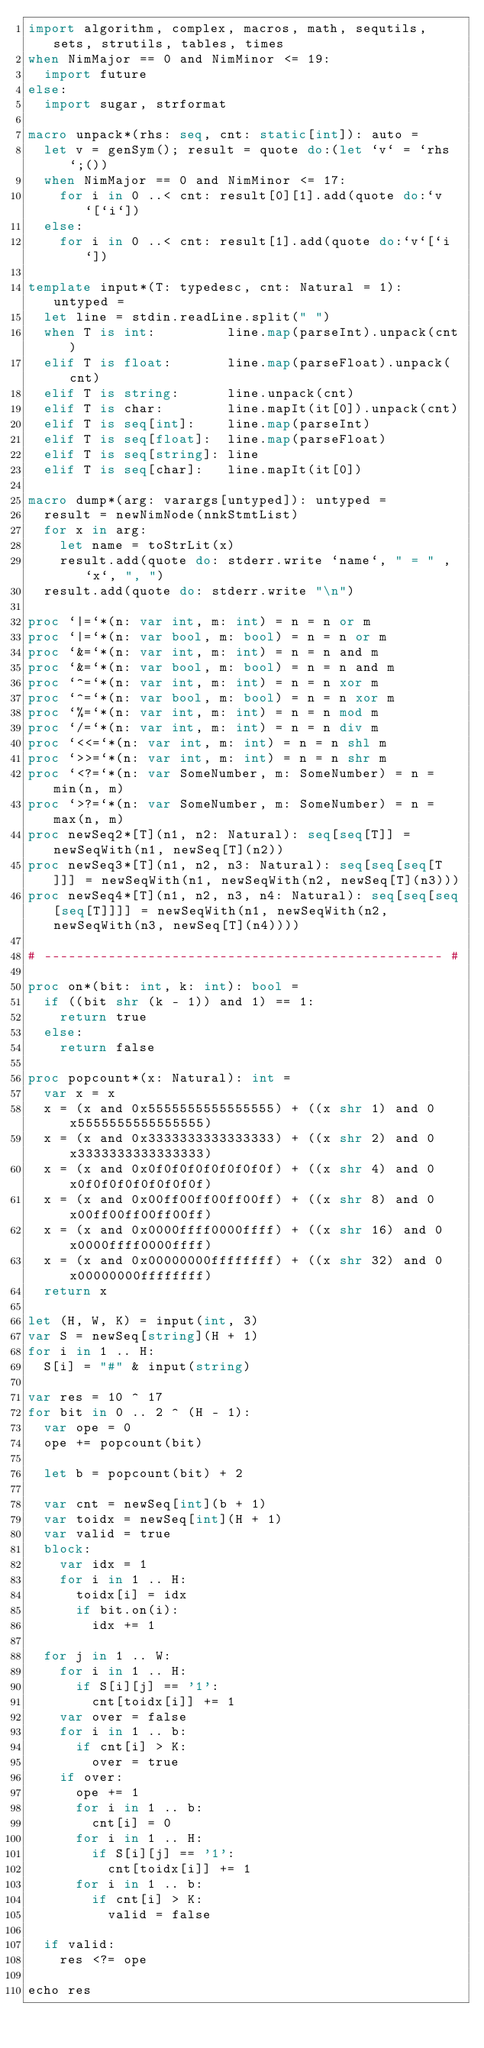<code> <loc_0><loc_0><loc_500><loc_500><_Nim_>import algorithm, complex, macros, math, sequtils, sets, strutils, tables, times
when NimMajor == 0 and NimMinor <= 19:
  import future
else:
  import sugar, strformat

macro unpack*(rhs: seq, cnt: static[int]): auto =
  let v = genSym(); result = quote do:(let `v` = `rhs`;())
  when NimMajor == 0 and NimMinor <= 17:
    for i in 0 ..< cnt: result[0][1].add(quote do:`v`[`i`])
  else:
    for i in 0 ..< cnt: result[1].add(quote do:`v`[`i`])

template input*(T: typedesc, cnt: Natural = 1): untyped =
  let line = stdin.readLine.split(" ")
  when T is int:         line.map(parseInt).unpack(cnt)
  elif T is float:       line.map(parseFloat).unpack(cnt)
  elif T is string:      line.unpack(cnt)
  elif T is char:        line.mapIt(it[0]).unpack(cnt)
  elif T is seq[int]:    line.map(parseInt)
  elif T is seq[float]:  line.map(parseFloat)
  elif T is seq[string]: line
  elif T is seq[char]:   line.mapIt(it[0])

macro dump*(arg: varargs[untyped]): untyped =
  result = newNimNode(nnkStmtList)
  for x in arg:
    let name = toStrLit(x)
    result.add(quote do: stderr.write `name`, " = " , `x`, ", ")
  result.add(quote do: stderr.write "\n")

proc `|=`*(n: var int, m: int) = n = n or m
proc `|=`*(n: var bool, m: bool) = n = n or m
proc `&=`*(n: var int, m: int) = n = n and m
proc `&=`*(n: var bool, m: bool) = n = n and m
proc `^=`*(n: var int, m: int) = n = n xor m
proc `^=`*(n: var bool, m: bool) = n = n xor m
proc `%=`*(n: var int, m: int) = n = n mod m
proc `/=`*(n: var int, m: int) = n = n div m
proc `<<=`*(n: var int, m: int) = n = n shl m
proc `>>=`*(n: var int, m: int) = n = n shr m
proc `<?=`*(n: var SomeNumber, m: SomeNumber) = n = min(n, m)
proc `>?=`*(n: var SomeNumber, m: SomeNumber) = n = max(n, m)
proc newSeq2*[T](n1, n2: Natural): seq[seq[T]] = newSeqWith(n1, newSeq[T](n2))
proc newSeq3*[T](n1, n2, n3: Natural): seq[seq[seq[T]]] = newSeqWith(n1, newSeqWith(n2, newSeq[T](n3)))
proc newSeq4*[T](n1, n2, n3, n4: Natural): seq[seq[seq[seq[T]]]] = newSeqWith(n1, newSeqWith(n2, newSeqWith(n3, newSeq[T](n4))))

# -------------------------------------------------- #

proc on*(bit: int, k: int): bool =
  if ((bit shr (k - 1)) and 1) == 1:
    return true
  else:
    return false

proc popcount*(x: Natural): int =
  var x = x
  x = (x and 0x5555555555555555) + ((x shr 1) and 0x5555555555555555)
  x = (x and 0x3333333333333333) + ((x shr 2) and 0x3333333333333333)
  x = (x and 0x0f0f0f0f0f0f0f0f) + ((x shr 4) and 0x0f0f0f0f0f0f0f0f)
  x = (x and 0x00ff00ff00ff00ff) + ((x shr 8) and 0x00ff00ff00ff00ff)
  x = (x and 0x0000ffff0000ffff) + ((x shr 16) and 0x0000ffff0000ffff)
  x = (x and 0x00000000ffffffff) + ((x shr 32) and 0x00000000ffffffff)
  return x

let (H, W, K) = input(int, 3)
var S = newSeq[string](H + 1)
for i in 1 .. H:
  S[i] = "#" & input(string)

var res = 10 ^ 17
for bit in 0 .. 2 ^ (H - 1):
  var ope = 0
  ope += popcount(bit)

  let b = popcount(bit) + 2

  var cnt = newSeq[int](b + 1)
  var toidx = newSeq[int](H + 1)
  var valid = true
  block:
    var idx = 1
    for i in 1 .. H:
      toidx[i] = idx
      if bit.on(i):
        idx += 1
  
  for j in 1 .. W:
    for i in 1 .. H:
      if S[i][j] == '1':
        cnt[toidx[i]] += 1
    var over = false
    for i in 1 .. b:
      if cnt[i] > K:
        over = true
    if over:
      ope += 1
      for i in 1 .. b:
        cnt[i] = 0
      for i in 1 .. H:
        if S[i][j] == '1':
          cnt[toidx[i]] += 1
      for i in 1 .. b:
        if cnt[i] > K:
          valid = false
  
  if valid:
    res <?= ope

echo res</code> 